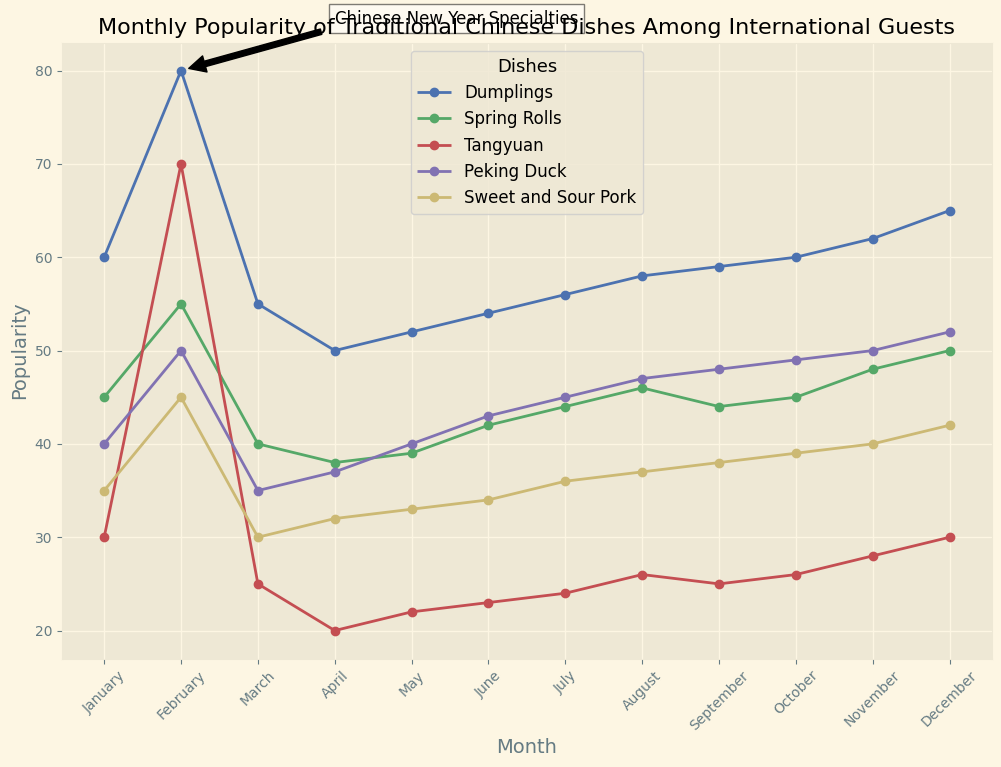What's the most popular dish in February? We look at February on the x-axis, and find the highest y-value under that month. Dumplings have the highest popularity with a value of 80.
Answer: Dumplings During which month did Dumplings reach their peak popularity? We look at the Dumplings' curve and find the highest point across all months. The peak value is in February.
Answer: February Which dish had a significant increase in popularity from January to February? Compare the differences in popularity between January and February for all dishes. Tangyuan increased from 30 to 70, which is the most significant.
Answer: Tangyuan What's the average popularity of Spring Rolls across the year? Sum the popularity of Spring Rolls across all months and divide by the number of months. (45 + 55 + 40 + 38 + 39 + 42 + 44 + 46 + 44 + 45 + 48 + 50) / 12 = 45.5
Answer: 45.5 What's the difference in popularity of Peking Duck between March and November? Look up the popularity values for Peking Duck in March and November, then subtract March's value from November's value. 50 - 35 = 15
Answer: 15 Which month shows the lowest popularity for Tangyuan? Examine Tangyuan's curve and locate the lowest point, which is in April with a value of 20.
Answer: April Describe the trend in popularity for Dumplings from January to December. There is an initial increase from January (60) to February (80), followed by a decrease in March (55) and April (50). The popularity then gradually increases through the latter months, peaking again in December (65).
Answer: Increasing-Decreasing-Increasing How does the popularity of Sweet and Sour Pork in October compare to that in March? Compare the values for Sweet and Sour Pork in October (39) and March (30). October's value is greater than March's.
Answer: Greater Which dish demonstrated the most consistent popularity throughout the year? Examine the curves for each dish for noticeable fluctuations. Dumplings shows the most consistent and generally increasing trend.
Answer: Dumplings For which dishes did the popularity peak occur during Chinese New Year (February)? Check each dish's popularity in February and compare it to other months. Dumplings and Tangyuan peaked in February.
Answer: Dumplings, Tangyuan 